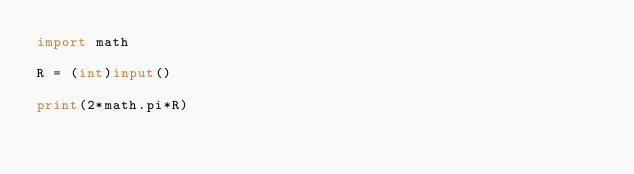<code> <loc_0><loc_0><loc_500><loc_500><_Python_>import math

R = (int)input()

print(2*math.pi*R)</code> 